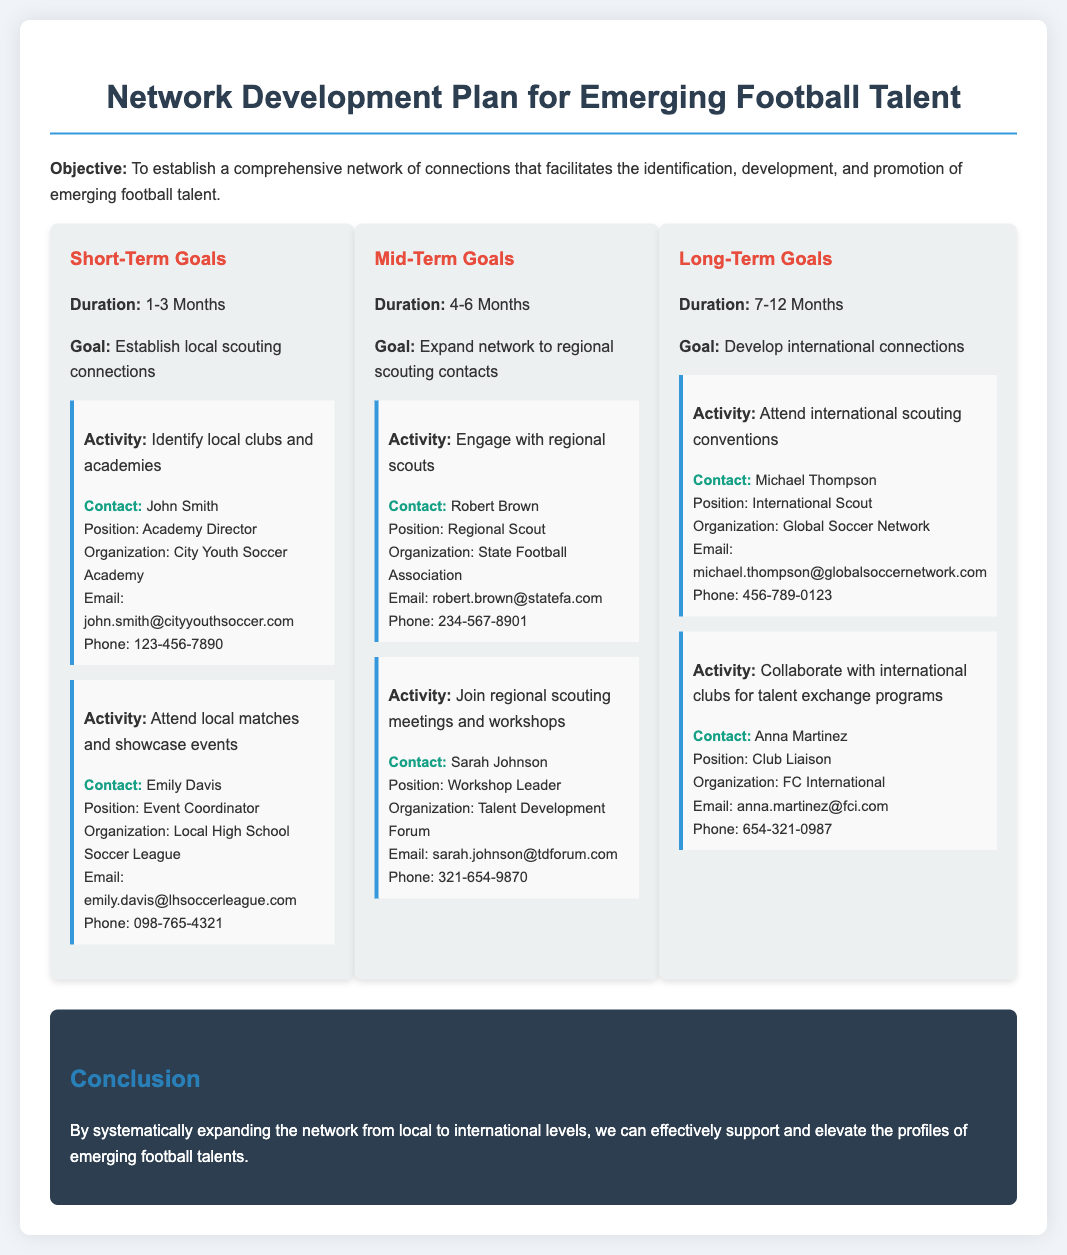what is the duration of the short-term goals? The short-term goals specify a duration of 1-3 Months.
Answer: 1-3 Months who is the Academy Director of City Youth Soccer Academy? The contact for City Youth Soccer Academy as the Academy Director is John Smith.
Answer: John Smith what is the goal of the mid-term goals? The mid-term goals aim to expand the network to regional scouting contacts.
Answer: Expand network to regional scouting contacts how long is the timeline for long-term goals? The long-term goals have a timeline of 7-12 Months.
Answer: 7-12 Months who should be contacted for attending international scouting conventions? The contact for attending international scouting conventions is Michael Thompson.
Answer: Michael Thompson what position does Sarah Johnson hold? Sarah Johnson is the Workshop Leader.
Answer: Workshop Leader how many activities are listed under short-term goals? The document lists two activities under short-term goals.
Answer: 2 what organization does Robert Brown work for? Robert Brown works for the State Football Association.
Answer: State Football Association what is the main objective of the Network Development Plan? The main objective is to establish a comprehensive network that facilitates the identification, development, and promotion of emerging football talent.
Answer: Establish a comprehensive network 